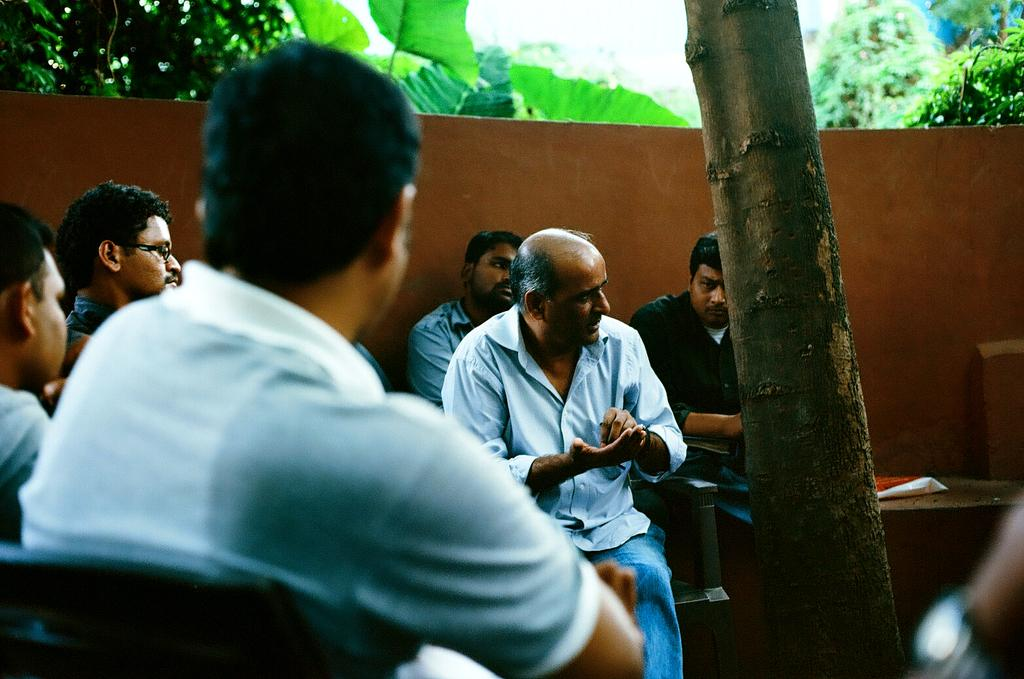How many people are in the image? There is a group of people in the image. What are the people doing in the image? The people are sitting on chairs. Is anyone speaking in the image? One person is talking. What can be seen in the background of the image? There is a wall and trees in the background of the image. What is located on the right side of the image? There is a table on the right side of the image. What type of thrill can be seen on the faces of the people in the image? There is no indication of any specific emotion or thrill on the faces of the people in the image. 